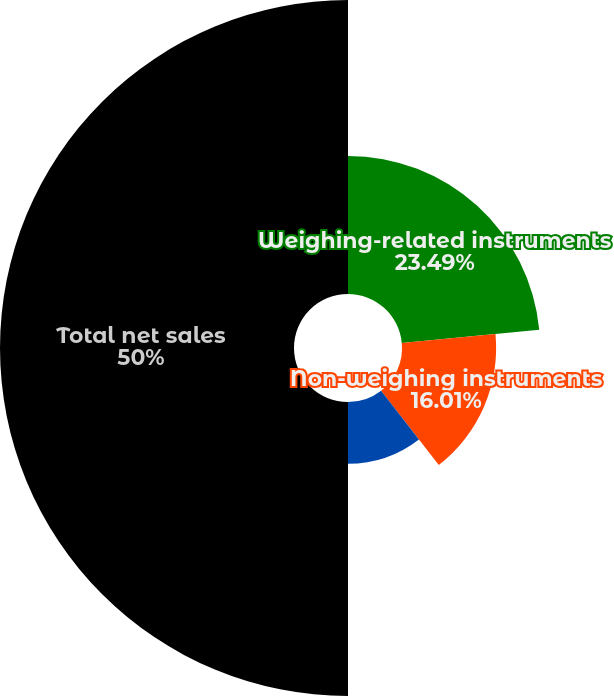<chart> <loc_0><loc_0><loc_500><loc_500><pie_chart><fcel>Weighing-related instruments<fcel>Non-weighing instruments<fcel>Service<fcel>Total net sales<nl><fcel>23.49%<fcel>16.01%<fcel>10.5%<fcel>50.0%<nl></chart> 